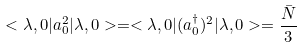Convert formula to latex. <formula><loc_0><loc_0><loc_500><loc_500>< \lambda , 0 | a _ { 0 } ^ { 2 } | \lambda , 0 > = < \lambda , 0 | ( a _ { 0 } ^ { \dagger } ) ^ { 2 } | \lambda , 0 > = \frac { \bar { N } } { 3 }</formula> 